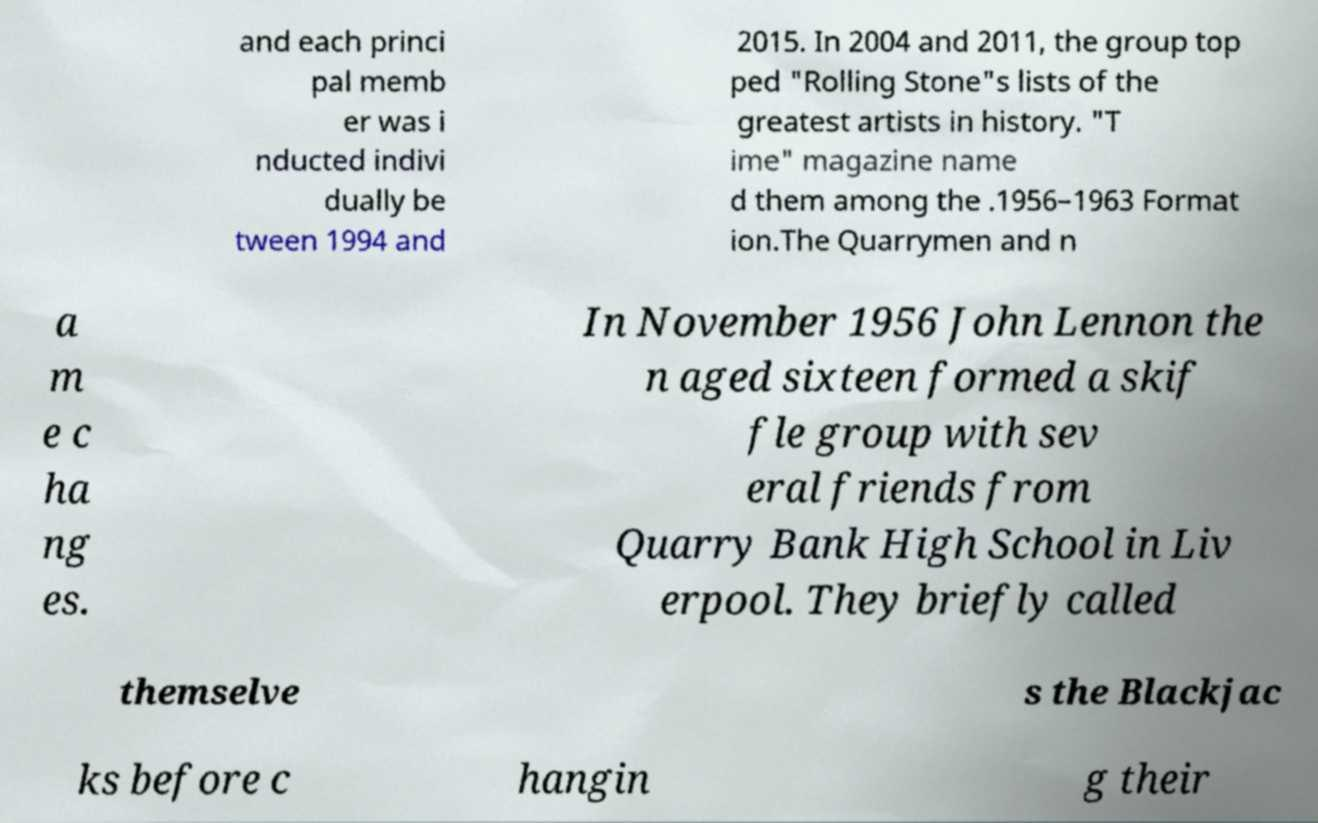What messages or text are displayed in this image? I need them in a readable, typed format. and each princi pal memb er was i nducted indivi dually be tween 1994 and 2015. In 2004 and 2011, the group top ped "Rolling Stone"s lists of the greatest artists in history. "T ime" magazine name d them among the .1956–1963 Format ion.The Quarrymen and n a m e c ha ng es. In November 1956 John Lennon the n aged sixteen formed a skif fle group with sev eral friends from Quarry Bank High School in Liv erpool. They briefly called themselve s the Blackjac ks before c hangin g their 